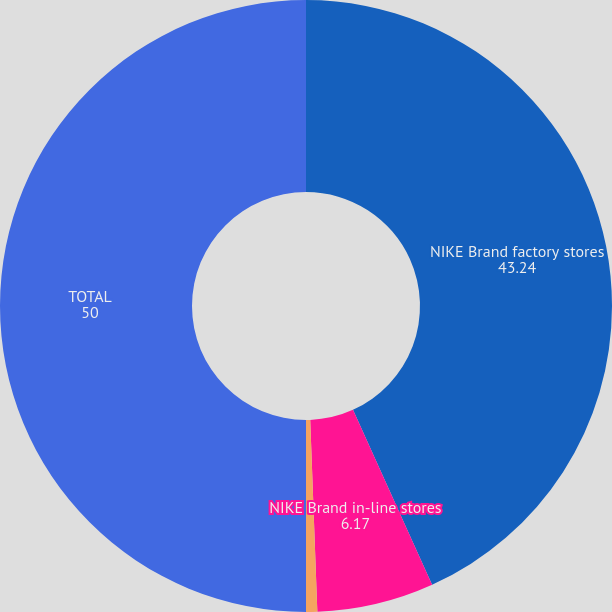<chart> <loc_0><loc_0><loc_500><loc_500><pie_chart><fcel>NIKE Brand factory stores<fcel>NIKE Brand in-line stores<fcel>Converse stores (including<fcel>TOTAL<nl><fcel>43.24%<fcel>6.17%<fcel>0.59%<fcel>50.0%<nl></chart> 